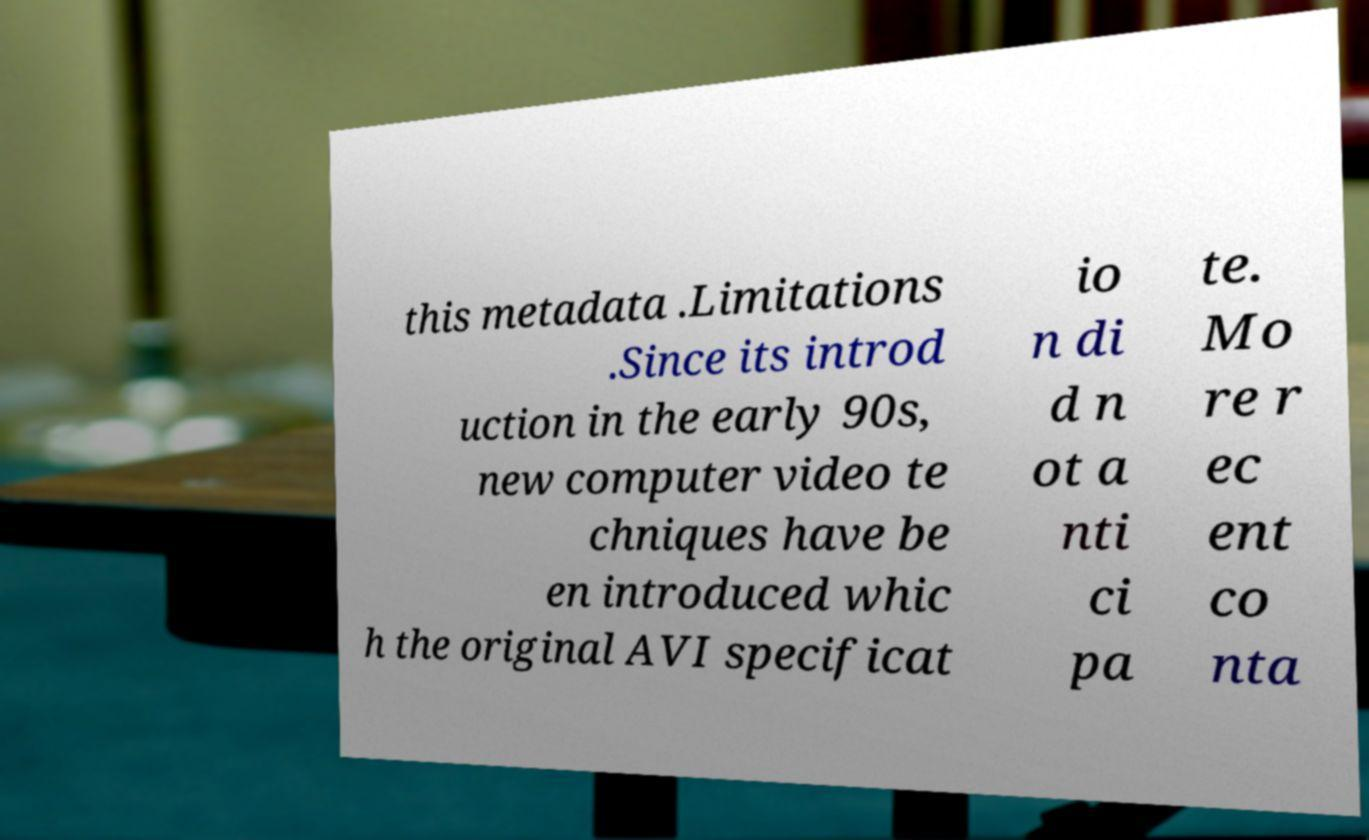Could you extract and type out the text from this image? this metadata .Limitations .Since its introd uction in the early 90s, new computer video te chniques have be en introduced whic h the original AVI specificat io n di d n ot a nti ci pa te. Mo re r ec ent co nta 